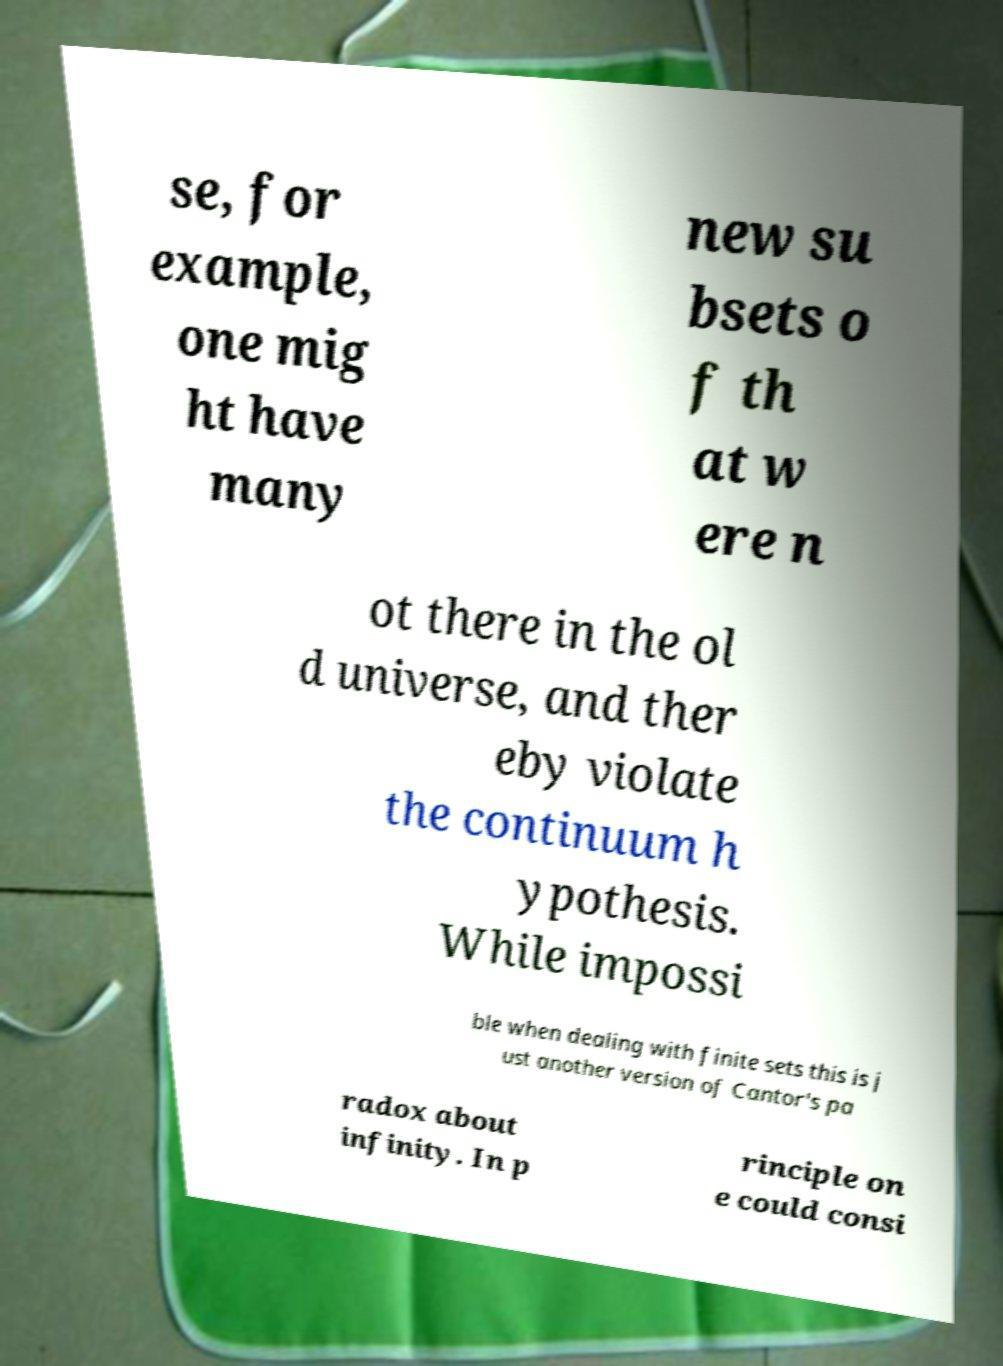Please read and relay the text visible in this image. What does it say? se, for example, one mig ht have many new su bsets o f th at w ere n ot there in the ol d universe, and ther eby violate the continuum h ypothesis. While impossi ble when dealing with finite sets this is j ust another version of Cantor's pa radox about infinity. In p rinciple on e could consi 